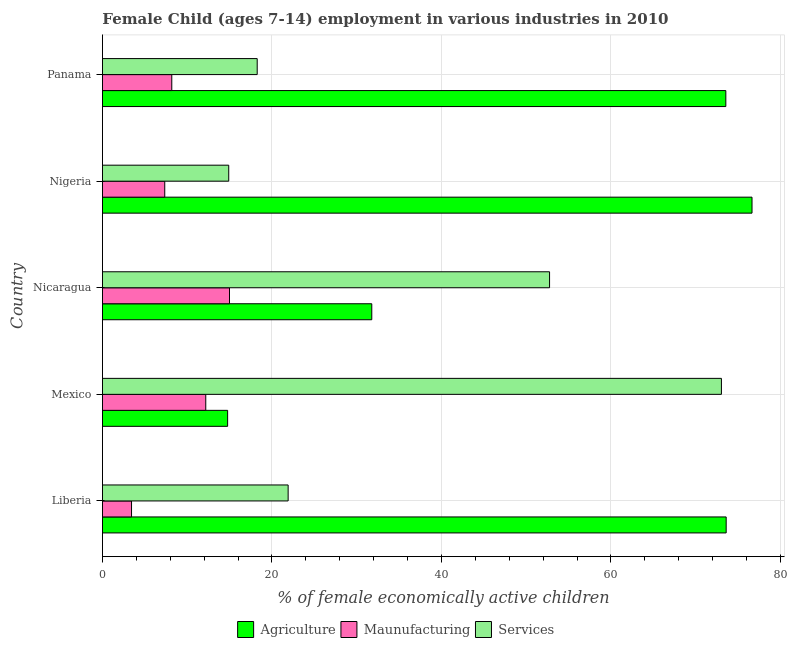How many groups of bars are there?
Ensure brevity in your answer.  5. Are the number of bars per tick equal to the number of legend labels?
Make the answer very short. Yes. Are the number of bars on each tick of the Y-axis equal?
Ensure brevity in your answer.  Yes. How many bars are there on the 1st tick from the bottom?
Ensure brevity in your answer.  3. What is the label of the 2nd group of bars from the top?
Your answer should be very brief. Nigeria. What is the percentage of economically active children in agriculture in Panama?
Your answer should be very brief. 73.56. Across all countries, what is the maximum percentage of economically active children in agriculture?
Offer a terse response. 76.65. Across all countries, what is the minimum percentage of economically active children in manufacturing?
Provide a short and direct response. 3.43. In which country was the percentage of economically active children in agriculture maximum?
Your answer should be compact. Nigeria. In which country was the percentage of economically active children in services minimum?
Offer a very short reply. Nigeria. What is the total percentage of economically active children in manufacturing in the graph?
Ensure brevity in your answer.  46.14. What is the difference between the percentage of economically active children in services in Mexico and that in Panama?
Make the answer very short. 54.78. What is the difference between the percentage of economically active children in manufacturing in Nigeria and the percentage of economically active children in agriculture in Nicaragua?
Your answer should be compact. -24.43. What is the average percentage of economically active children in services per country?
Ensure brevity in your answer.  36.17. What is the difference between the percentage of economically active children in manufacturing and percentage of economically active children in services in Nigeria?
Provide a succinct answer. -7.55. What is the ratio of the percentage of economically active children in manufacturing in Mexico to that in Nicaragua?
Your answer should be compact. 0.81. Is the percentage of economically active children in manufacturing in Mexico less than that in Nigeria?
Your response must be concise. No. Is the difference between the percentage of economically active children in agriculture in Mexico and Nigeria greater than the difference between the percentage of economically active children in manufacturing in Mexico and Nigeria?
Provide a short and direct response. No. What is the difference between the highest and the lowest percentage of economically active children in manufacturing?
Your response must be concise. 11.56. In how many countries, is the percentage of economically active children in manufacturing greater than the average percentage of economically active children in manufacturing taken over all countries?
Give a very brief answer. 2. What does the 1st bar from the top in Nigeria represents?
Provide a short and direct response. Services. What does the 1st bar from the bottom in Liberia represents?
Offer a very short reply. Agriculture. How many bars are there?
Your answer should be compact. 15. Does the graph contain any zero values?
Your answer should be very brief. No. Does the graph contain grids?
Make the answer very short. Yes. Where does the legend appear in the graph?
Your answer should be very brief. Bottom center. How are the legend labels stacked?
Give a very brief answer. Horizontal. What is the title of the graph?
Offer a terse response. Female Child (ages 7-14) employment in various industries in 2010. Does "Industry" appear as one of the legend labels in the graph?
Make the answer very short. No. What is the label or title of the X-axis?
Make the answer very short. % of female economically active children. What is the label or title of the Y-axis?
Your response must be concise. Country. What is the % of female economically active children of Agriculture in Liberia?
Keep it short and to the point. 73.6. What is the % of female economically active children of Maunufacturing in Liberia?
Your answer should be very brief. 3.43. What is the % of female economically active children of Services in Liberia?
Keep it short and to the point. 21.91. What is the % of female economically active children of Agriculture in Mexico?
Provide a short and direct response. 14.77. What is the % of female economically active children in Maunufacturing in Mexico?
Make the answer very short. 12.19. What is the % of female economically active children of Services in Mexico?
Make the answer very short. 73.04. What is the % of female economically active children in Agriculture in Nicaragua?
Your answer should be very brief. 31.78. What is the % of female economically active children in Maunufacturing in Nicaragua?
Your answer should be very brief. 14.99. What is the % of female economically active children in Services in Nicaragua?
Provide a succinct answer. 52.76. What is the % of female economically active children in Agriculture in Nigeria?
Give a very brief answer. 76.65. What is the % of female economically active children of Maunufacturing in Nigeria?
Make the answer very short. 7.35. What is the % of female economically active children in Services in Nigeria?
Your answer should be very brief. 14.9. What is the % of female economically active children in Agriculture in Panama?
Offer a very short reply. 73.56. What is the % of female economically active children in Maunufacturing in Panama?
Offer a very short reply. 8.18. What is the % of female economically active children in Services in Panama?
Keep it short and to the point. 18.26. Across all countries, what is the maximum % of female economically active children of Agriculture?
Provide a succinct answer. 76.65. Across all countries, what is the maximum % of female economically active children in Maunufacturing?
Your answer should be very brief. 14.99. Across all countries, what is the maximum % of female economically active children in Services?
Your answer should be very brief. 73.04. Across all countries, what is the minimum % of female economically active children of Agriculture?
Your answer should be compact. 14.77. Across all countries, what is the minimum % of female economically active children of Maunufacturing?
Keep it short and to the point. 3.43. What is the total % of female economically active children in Agriculture in the graph?
Your answer should be very brief. 270.36. What is the total % of female economically active children of Maunufacturing in the graph?
Provide a short and direct response. 46.14. What is the total % of female economically active children in Services in the graph?
Provide a succinct answer. 180.87. What is the difference between the % of female economically active children of Agriculture in Liberia and that in Mexico?
Provide a short and direct response. 58.83. What is the difference between the % of female economically active children of Maunufacturing in Liberia and that in Mexico?
Make the answer very short. -8.76. What is the difference between the % of female economically active children in Services in Liberia and that in Mexico?
Offer a terse response. -51.13. What is the difference between the % of female economically active children in Agriculture in Liberia and that in Nicaragua?
Make the answer very short. 41.82. What is the difference between the % of female economically active children of Maunufacturing in Liberia and that in Nicaragua?
Keep it short and to the point. -11.56. What is the difference between the % of female economically active children in Services in Liberia and that in Nicaragua?
Give a very brief answer. -30.85. What is the difference between the % of female economically active children in Agriculture in Liberia and that in Nigeria?
Give a very brief answer. -3.05. What is the difference between the % of female economically active children of Maunufacturing in Liberia and that in Nigeria?
Keep it short and to the point. -3.92. What is the difference between the % of female economically active children in Services in Liberia and that in Nigeria?
Make the answer very short. 7.01. What is the difference between the % of female economically active children in Maunufacturing in Liberia and that in Panama?
Make the answer very short. -4.75. What is the difference between the % of female economically active children in Services in Liberia and that in Panama?
Keep it short and to the point. 3.65. What is the difference between the % of female economically active children of Agriculture in Mexico and that in Nicaragua?
Keep it short and to the point. -17.01. What is the difference between the % of female economically active children of Services in Mexico and that in Nicaragua?
Offer a terse response. 20.28. What is the difference between the % of female economically active children in Agriculture in Mexico and that in Nigeria?
Ensure brevity in your answer.  -61.88. What is the difference between the % of female economically active children of Maunufacturing in Mexico and that in Nigeria?
Provide a succinct answer. 4.84. What is the difference between the % of female economically active children in Services in Mexico and that in Nigeria?
Provide a succinct answer. 58.14. What is the difference between the % of female economically active children of Agriculture in Mexico and that in Panama?
Your response must be concise. -58.79. What is the difference between the % of female economically active children of Maunufacturing in Mexico and that in Panama?
Make the answer very short. 4.01. What is the difference between the % of female economically active children in Services in Mexico and that in Panama?
Provide a succinct answer. 54.78. What is the difference between the % of female economically active children of Agriculture in Nicaragua and that in Nigeria?
Your response must be concise. -44.87. What is the difference between the % of female economically active children in Maunufacturing in Nicaragua and that in Nigeria?
Make the answer very short. 7.64. What is the difference between the % of female economically active children of Services in Nicaragua and that in Nigeria?
Your answer should be compact. 37.86. What is the difference between the % of female economically active children in Agriculture in Nicaragua and that in Panama?
Offer a very short reply. -41.78. What is the difference between the % of female economically active children in Maunufacturing in Nicaragua and that in Panama?
Make the answer very short. 6.81. What is the difference between the % of female economically active children of Services in Nicaragua and that in Panama?
Provide a succinct answer. 34.5. What is the difference between the % of female economically active children of Agriculture in Nigeria and that in Panama?
Ensure brevity in your answer.  3.09. What is the difference between the % of female economically active children of Maunufacturing in Nigeria and that in Panama?
Offer a very short reply. -0.83. What is the difference between the % of female economically active children of Services in Nigeria and that in Panama?
Your answer should be very brief. -3.36. What is the difference between the % of female economically active children in Agriculture in Liberia and the % of female economically active children in Maunufacturing in Mexico?
Offer a very short reply. 61.41. What is the difference between the % of female economically active children in Agriculture in Liberia and the % of female economically active children in Services in Mexico?
Ensure brevity in your answer.  0.56. What is the difference between the % of female economically active children of Maunufacturing in Liberia and the % of female economically active children of Services in Mexico?
Ensure brevity in your answer.  -69.61. What is the difference between the % of female economically active children of Agriculture in Liberia and the % of female economically active children of Maunufacturing in Nicaragua?
Give a very brief answer. 58.61. What is the difference between the % of female economically active children in Agriculture in Liberia and the % of female economically active children in Services in Nicaragua?
Offer a very short reply. 20.84. What is the difference between the % of female economically active children in Maunufacturing in Liberia and the % of female economically active children in Services in Nicaragua?
Your answer should be very brief. -49.33. What is the difference between the % of female economically active children in Agriculture in Liberia and the % of female economically active children in Maunufacturing in Nigeria?
Ensure brevity in your answer.  66.25. What is the difference between the % of female economically active children of Agriculture in Liberia and the % of female economically active children of Services in Nigeria?
Keep it short and to the point. 58.7. What is the difference between the % of female economically active children in Maunufacturing in Liberia and the % of female economically active children in Services in Nigeria?
Your answer should be compact. -11.47. What is the difference between the % of female economically active children in Agriculture in Liberia and the % of female economically active children in Maunufacturing in Panama?
Your answer should be compact. 65.42. What is the difference between the % of female economically active children in Agriculture in Liberia and the % of female economically active children in Services in Panama?
Your answer should be very brief. 55.34. What is the difference between the % of female economically active children in Maunufacturing in Liberia and the % of female economically active children in Services in Panama?
Your answer should be compact. -14.83. What is the difference between the % of female economically active children of Agriculture in Mexico and the % of female economically active children of Maunufacturing in Nicaragua?
Offer a terse response. -0.22. What is the difference between the % of female economically active children in Agriculture in Mexico and the % of female economically active children in Services in Nicaragua?
Offer a terse response. -37.99. What is the difference between the % of female economically active children in Maunufacturing in Mexico and the % of female economically active children in Services in Nicaragua?
Provide a succinct answer. -40.57. What is the difference between the % of female economically active children in Agriculture in Mexico and the % of female economically active children in Maunufacturing in Nigeria?
Provide a short and direct response. 7.42. What is the difference between the % of female economically active children in Agriculture in Mexico and the % of female economically active children in Services in Nigeria?
Your answer should be compact. -0.13. What is the difference between the % of female economically active children in Maunufacturing in Mexico and the % of female economically active children in Services in Nigeria?
Give a very brief answer. -2.71. What is the difference between the % of female economically active children in Agriculture in Mexico and the % of female economically active children in Maunufacturing in Panama?
Give a very brief answer. 6.59. What is the difference between the % of female economically active children in Agriculture in Mexico and the % of female economically active children in Services in Panama?
Your answer should be compact. -3.49. What is the difference between the % of female economically active children in Maunufacturing in Mexico and the % of female economically active children in Services in Panama?
Give a very brief answer. -6.07. What is the difference between the % of female economically active children of Agriculture in Nicaragua and the % of female economically active children of Maunufacturing in Nigeria?
Your answer should be compact. 24.43. What is the difference between the % of female economically active children in Agriculture in Nicaragua and the % of female economically active children in Services in Nigeria?
Your response must be concise. 16.88. What is the difference between the % of female economically active children of Maunufacturing in Nicaragua and the % of female economically active children of Services in Nigeria?
Provide a succinct answer. 0.09. What is the difference between the % of female economically active children in Agriculture in Nicaragua and the % of female economically active children in Maunufacturing in Panama?
Offer a terse response. 23.6. What is the difference between the % of female economically active children in Agriculture in Nicaragua and the % of female economically active children in Services in Panama?
Your answer should be very brief. 13.52. What is the difference between the % of female economically active children of Maunufacturing in Nicaragua and the % of female economically active children of Services in Panama?
Give a very brief answer. -3.27. What is the difference between the % of female economically active children in Agriculture in Nigeria and the % of female economically active children in Maunufacturing in Panama?
Keep it short and to the point. 68.47. What is the difference between the % of female economically active children of Agriculture in Nigeria and the % of female economically active children of Services in Panama?
Make the answer very short. 58.39. What is the difference between the % of female economically active children in Maunufacturing in Nigeria and the % of female economically active children in Services in Panama?
Make the answer very short. -10.91. What is the average % of female economically active children of Agriculture per country?
Provide a succinct answer. 54.07. What is the average % of female economically active children in Maunufacturing per country?
Keep it short and to the point. 9.23. What is the average % of female economically active children in Services per country?
Ensure brevity in your answer.  36.17. What is the difference between the % of female economically active children in Agriculture and % of female economically active children in Maunufacturing in Liberia?
Offer a terse response. 70.17. What is the difference between the % of female economically active children of Agriculture and % of female economically active children of Services in Liberia?
Provide a succinct answer. 51.69. What is the difference between the % of female economically active children in Maunufacturing and % of female economically active children in Services in Liberia?
Your answer should be very brief. -18.48. What is the difference between the % of female economically active children of Agriculture and % of female economically active children of Maunufacturing in Mexico?
Your answer should be very brief. 2.58. What is the difference between the % of female economically active children in Agriculture and % of female economically active children in Services in Mexico?
Provide a succinct answer. -58.27. What is the difference between the % of female economically active children in Maunufacturing and % of female economically active children in Services in Mexico?
Provide a succinct answer. -60.85. What is the difference between the % of female economically active children in Agriculture and % of female economically active children in Maunufacturing in Nicaragua?
Keep it short and to the point. 16.79. What is the difference between the % of female economically active children in Agriculture and % of female economically active children in Services in Nicaragua?
Your response must be concise. -20.98. What is the difference between the % of female economically active children in Maunufacturing and % of female economically active children in Services in Nicaragua?
Your response must be concise. -37.77. What is the difference between the % of female economically active children in Agriculture and % of female economically active children in Maunufacturing in Nigeria?
Offer a very short reply. 69.3. What is the difference between the % of female economically active children of Agriculture and % of female economically active children of Services in Nigeria?
Your response must be concise. 61.75. What is the difference between the % of female economically active children in Maunufacturing and % of female economically active children in Services in Nigeria?
Ensure brevity in your answer.  -7.55. What is the difference between the % of female economically active children of Agriculture and % of female economically active children of Maunufacturing in Panama?
Your answer should be very brief. 65.38. What is the difference between the % of female economically active children of Agriculture and % of female economically active children of Services in Panama?
Keep it short and to the point. 55.3. What is the difference between the % of female economically active children in Maunufacturing and % of female economically active children in Services in Panama?
Ensure brevity in your answer.  -10.08. What is the ratio of the % of female economically active children of Agriculture in Liberia to that in Mexico?
Keep it short and to the point. 4.98. What is the ratio of the % of female economically active children in Maunufacturing in Liberia to that in Mexico?
Provide a short and direct response. 0.28. What is the ratio of the % of female economically active children of Services in Liberia to that in Mexico?
Ensure brevity in your answer.  0.3. What is the ratio of the % of female economically active children of Agriculture in Liberia to that in Nicaragua?
Give a very brief answer. 2.32. What is the ratio of the % of female economically active children of Maunufacturing in Liberia to that in Nicaragua?
Provide a short and direct response. 0.23. What is the ratio of the % of female economically active children in Services in Liberia to that in Nicaragua?
Your response must be concise. 0.42. What is the ratio of the % of female economically active children of Agriculture in Liberia to that in Nigeria?
Offer a very short reply. 0.96. What is the ratio of the % of female economically active children of Maunufacturing in Liberia to that in Nigeria?
Offer a terse response. 0.47. What is the ratio of the % of female economically active children of Services in Liberia to that in Nigeria?
Offer a terse response. 1.47. What is the ratio of the % of female economically active children of Agriculture in Liberia to that in Panama?
Keep it short and to the point. 1. What is the ratio of the % of female economically active children in Maunufacturing in Liberia to that in Panama?
Offer a very short reply. 0.42. What is the ratio of the % of female economically active children in Services in Liberia to that in Panama?
Make the answer very short. 1.2. What is the ratio of the % of female economically active children of Agriculture in Mexico to that in Nicaragua?
Offer a very short reply. 0.46. What is the ratio of the % of female economically active children in Maunufacturing in Mexico to that in Nicaragua?
Give a very brief answer. 0.81. What is the ratio of the % of female economically active children of Services in Mexico to that in Nicaragua?
Make the answer very short. 1.38. What is the ratio of the % of female economically active children in Agriculture in Mexico to that in Nigeria?
Make the answer very short. 0.19. What is the ratio of the % of female economically active children of Maunufacturing in Mexico to that in Nigeria?
Provide a short and direct response. 1.66. What is the ratio of the % of female economically active children of Services in Mexico to that in Nigeria?
Offer a very short reply. 4.9. What is the ratio of the % of female economically active children in Agriculture in Mexico to that in Panama?
Give a very brief answer. 0.2. What is the ratio of the % of female economically active children of Maunufacturing in Mexico to that in Panama?
Ensure brevity in your answer.  1.49. What is the ratio of the % of female economically active children in Agriculture in Nicaragua to that in Nigeria?
Make the answer very short. 0.41. What is the ratio of the % of female economically active children in Maunufacturing in Nicaragua to that in Nigeria?
Your answer should be compact. 2.04. What is the ratio of the % of female economically active children of Services in Nicaragua to that in Nigeria?
Your answer should be very brief. 3.54. What is the ratio of the % of female economically active children of Agriculture in Nicaragua to that in Panama?
Ensure brevity in your answer.  0.43. What is the ratio of the % of female economically active children of Maunufacturing in Nicaragua to that in Panama?
Your answer should be very brief. 1.83. What is the ratio of the % of female economically active children in Services in Nicaragua to that in Panama?
Provide a succinct answer. 2.89. What is the ratio of the % of female economically active children in Agriculture in Nigeria to that in Panama?
Give a very brief answer. 1.04. What is the ratio of the % of female economically active children in Maunufacturing in Nigeria to that in Panama?
Your answer should be very brief. 0.9. What is the ratio of the % of female economically active children in Services in Nigeria to that in Panama?
Your answer should be compact. 0.82. What is the difference between the highest and the second highest % of female economically active children of Agriculture?
Make the answer very short. 3.05. What is the difference between the highest and the second highest % of female economically active children of Services?
Keep it short and to the point. 20.28. What is the difference between the highest and the lowest % of female economically active children of Agriculture?
Offer a very short reply. 61.88. What is the difference between the highest and the lowest % of female economically active children of Maunufacturing?
Provide a short and direct response. 11.56. What is the difference between the highest and the lowest % of female economically active children in Services?
Provide a short and direct response. 58.14. 